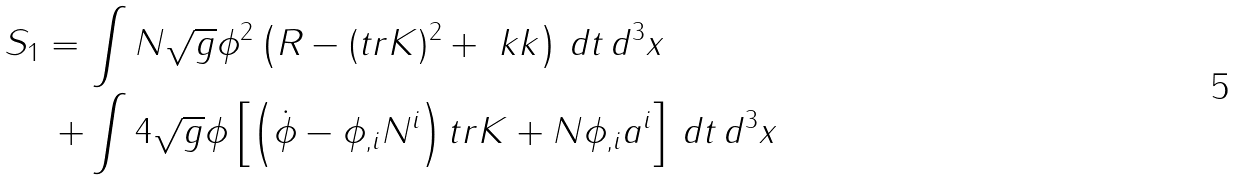Convert formula to latex. <formula><loc_0><loc_0><loc_500><loc_500>S _ { 1 } = \, & \int N \sqrt { g } \phi ^ { 2 } \left ( R - ( t r K ) ^ { 2 } + \ k k \right ) \, d t \, d ^ { 3 } x \\ + & \int 4 \sqrt { g } \phi \left [ \left ( \dot { \phi } - \phi _ { , i } N ^ { i } \right ) t r K + N \phi _ { , i } a ^ { i } \right ] \, d t \, d ^ { 3 } x</formula> 